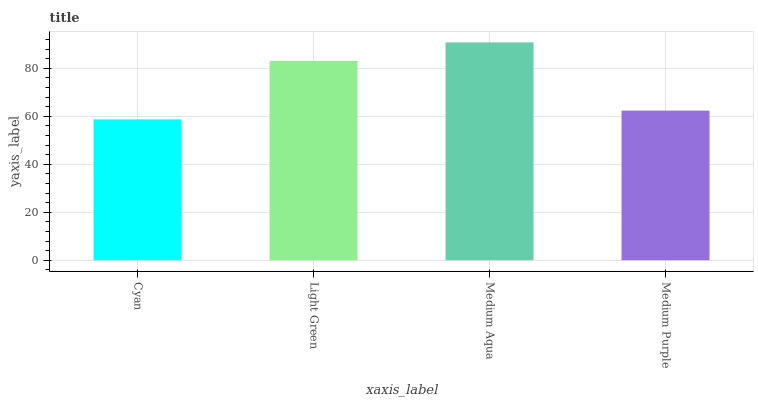Is Light Green the minimum?
Answer yes or no. No. Is Light Green the maximum?
Answer yes or no. No. Is Light Green greater than Cyan?
Answer yes or no. Yes. Is Cyan less than Light Green?
Answer yes or no. Yes. Is Cyan greater than Light Green?
Answer yes or no. No. Is Light Green less than Cyan?
Answer yes or no. No. Is Light Green the high median?
Answer yes or no. Yes. Is Medium Purple the low median?
Answer yes or no. Yes. Is Medium Purple the high median?
Answer yes or no. No. Is Light Green the low median?
Answer yes or no. No. 